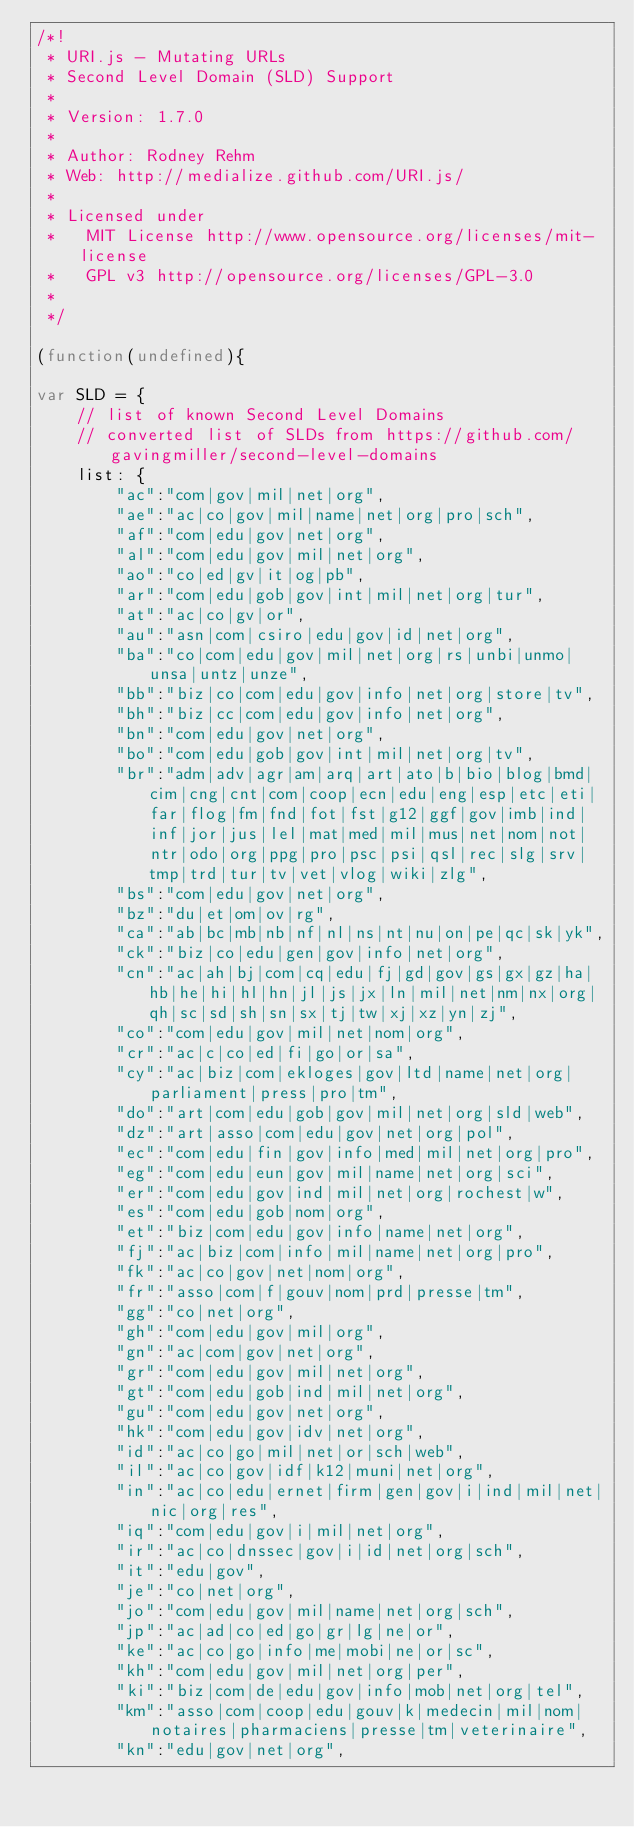Convert code to text. <code><loc_0><loc_0><loc_500><loc_500><_JavaScript_>/*!
 * URI.js - Mutating URLs
 * Second Level Domain (SLD) Support
 *
 * Version: 1.7.0
 *
 * Author: Rodney Rehm
 * Web: http://medialize.github.com/URI.js/
 *
 * Licensed under
 *   MIT License http://www.opensource.org/licenses/mit-license
 *   GPL v3 http://opensource.org/licenses/GPL-3.0
 *
 */

(function(undefined){

var SLD = {
    // list of known Second Level Domains
    // converted list of SLDs from https://github.com/gavingmiller/second-level-domains
    list: {
        "ac":"com|gov|mil|net|org",
        "ae":"ac|co|gov|mil|name|net|org|pro|sch",
        "af":"com|edu|gov|net|org",
        "al":"com|edu|gov|mil|net|org",
        "ao":"co|ed|gv|it|og|pb",
        "ar":"com|edu|gob|gov|int|mil|net|org|tur",
        "at":"ac|co|gv|or",
        "au":"asn|com|csiro|edu|gov|id|net|org",
        "ba":"co|com|edu|gov|mil|net|org|rs|unbi|unmo|unsa|untz|unze",
        "bb":"biz|co|com|edu|gov|info|net|org|store|tv",
        "bh":"biz|cc|com|edu|gov|info|net|org",
        "bn":"com|edu|gov|net|org",
        "bo":"com|edu|gob|gov|int|mil|net|org|tv",
        "br":"adm|adv|agr|am|arq|art|ato|b|bio|blog|bmd|cim|cng|cnt|com|coop|ecn|edu|eng|esp|etc|eti|far|flog|fm|fnd|fot|fst|g12|ggf|gov|imb|ind|inf|jor|jus|lel|mat|med|mil|mus|net|nom|not|ntr|odo|org|ppg|pro|psc|psi|qsl|rec|slg|srv|tmp|trd|tur|tv|vet|vlog|wiki|zlg",
        "bs":"com|edu|gov|net|org",
        "bz":"du|et|om|ov|rg",
        "ca":"ab|bc|mb|nb|nf|nl|ns|nt|nu|on|pe|qc|sk|yk",
        "ck":"biz|co|edu|gen|gov|info|net|org",
        "cn":"ac|ah|bj|com|cq|edu|fj|gd|gov|gs|gx|gz|ha|hb|he|hi|hl|hn|jl|js|jx|ln|mil|net|nm|nx|org|qh|sc|sd|sh|sn|sx|tj|tw|xj|xz|yn|zj",
        "co":"com|edu|gov|mil|net|nom|org",
        "cr":"ac|c|co|ed|fi|go|or|sa",
        "cy":"ac|biz|com|ekloges|gov|ltd|name|net|org|parliament|press|pro|tm",
        "do":"art|com|edu|gob|gov|mil|net|org|sld|web",
        "dz":"art|asso|com|edu|gov|net|org|pol",
        "ec":"com|edu|fin|gov|info|med|mil|net|org|pro",
        "eg":"com|edu|eun|gov|mil|name|net|org|sci",
        "er":"com|edu|gov|ind|mil|net|org|rochest|w",
        "es":"com|edu|gob|nom|org",
        "et":"biz|com|edu|gov|info|name|net|org",
        "fj":"ac|biz|com|info|mil|name|net|org|pro",
        "fk":"ac|co|gov|net|nom|org",
        "fr":"asso|com|f|gouv|nom|prd|presse|tm",
        "gg":"co|net|org",
        "gh":"com|edu|gov|mil|org",
        "gn":"ac|com|gov|net|org",
        "gr":"com|edu|gov|mil|net|org",
        "gt":"com|edu|gob|ind|mil|net|org",
        "gu":"com|edu|gov|net|org",
        "hk":"com|edu|gov|idv|net|org",
        "id":"ac|co|go|mil|net|or|sch|web",
        "il":"ac|co|gov|idf|k12|muni|net|org",
        "in":"ac|co|edu|ernet|firm|gen|gov|i|ind|mil|net|nic|org|res",
        "iq":"com|edu|gov|i|mil|net|org",
        "ir":"ac|co|dnssec|gov|i|id|net|org|sch",
        "it":"edu|gov",
        "je":"co|net|org",
        "jo":"com|edu|gov|mil|name|net|org|sch",
        "jp":"ac|ad|co|ed|go|gr|lg|ne|or",
        "ke":"ac|co|go|info|me|mobi|ne|or|sc",
        "kh":"com|edu|gov|mil|net|org|per",
        "ki":"biz|com|de|edu|gov|info|mob|net|org|tel",
        "km":"asso|com|coop|edu|gouv|k|medecin|mil|nom|notaires|pharmaciens|presse|tm|veterinaire",
        "kn":"edu|gov|net|org",</code> 